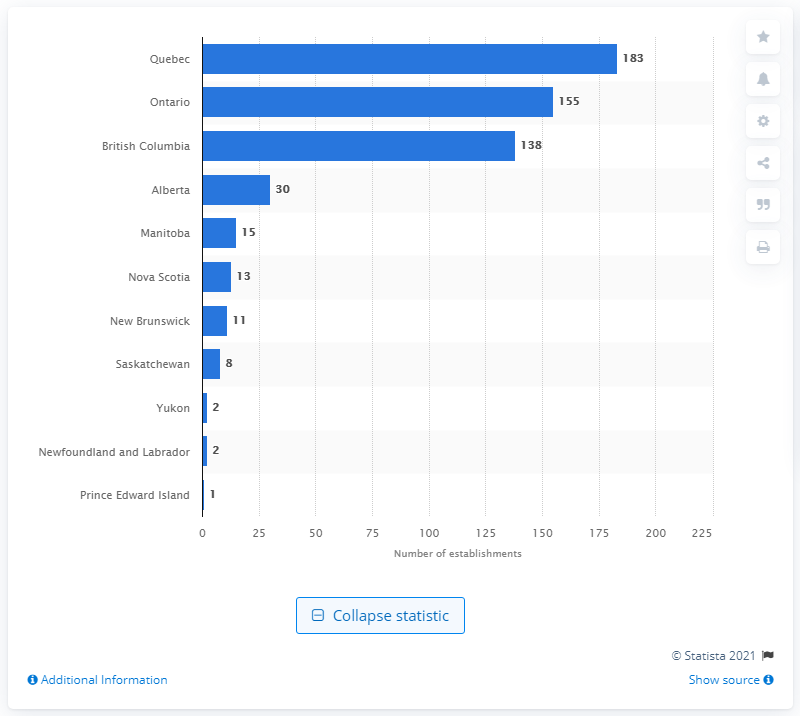Point out several critical features in this image. On Prince Edward Island, the only store that was stocked with the highest number of cycling equipment and supplies was located. 